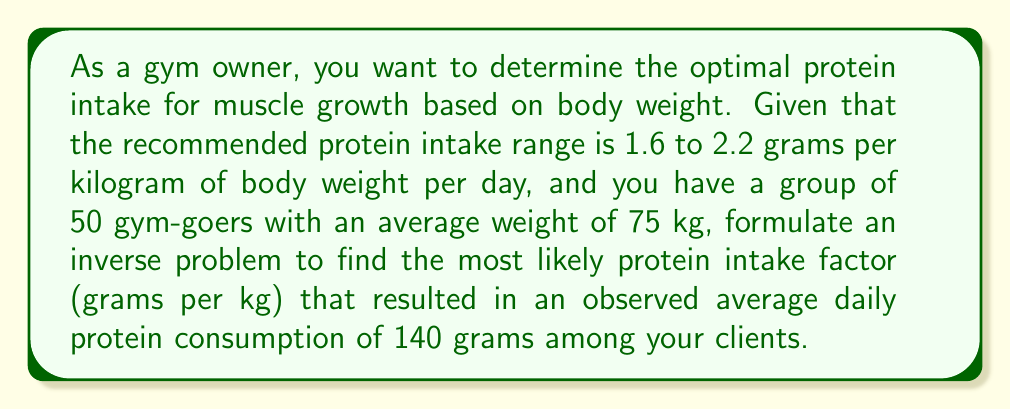Give your solution to this math problem. To solve this inverse problem, we'll use a simple linear model and the least squares method:

1. Let $x$ be the protein intake factor in g/kg/day.
2. The forward model is: $f(x) = 75x$, where 75 is the average weight in kg.
3. The observed data is $y = 140$ g/day.

We want to minimize the squared difference between the model prediction and the observed data:

$$\min_x (f(x) - y)^2 = \min_x (75x - 140)^2$$

To find the minimum, we differentiate with respect to $x$ and set it to zero:

$$\frac{d}{dx}(75x - 140)^2 = 2(75x - 140) \cdot 75 = 0$$

Solving this equation:

$$11250x - 21000 = 0$$
$$11250x = 21000$$
$$x = \frac{21000}{11250} = \frac{28}{15} \approx 1.87$$

This value of $x$ minimizes the squared difference and represents the most likely protein intake factor given the observed data.

To verify that this is within the recommended range:
$$1.6 \leq 1.87 \leq 2.2$$

Therefore, the calculated protein intake factor is within the recommended range.
Answer: 1.87 g/kg/day 